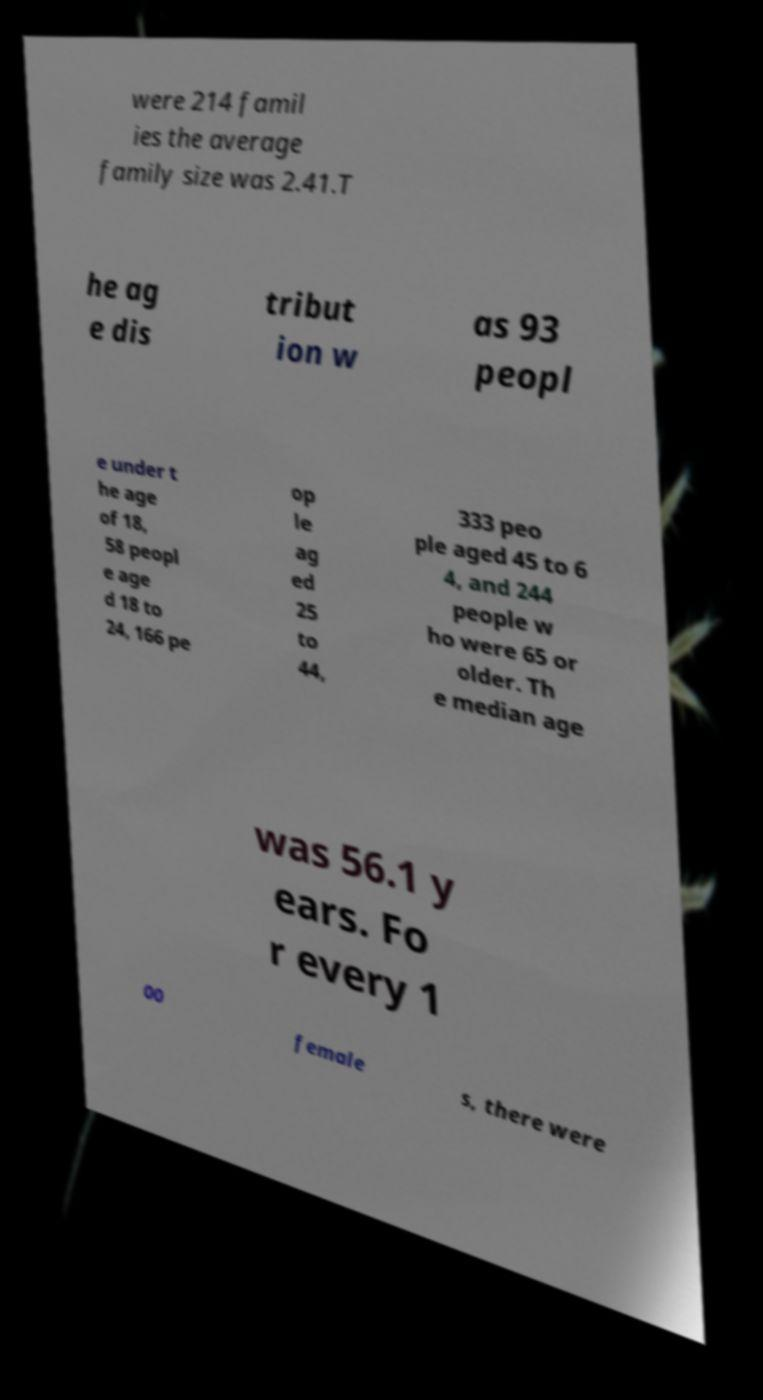I need the written content from this picture converted into text. Can you do that? were 214 famil ies the average family size was 2.41.T he ag e dis tribut ion w as 93 peopl e under t he age of 18, 58 peopl e age d 18 to 24, 166 pe op le ag ed 25 to 44, 333 peo ple aged 45 to 6 4, and 244 people w ho were 65 or older. Th e median age was 56.1 y ears. Fo r every 1 00 female s, there were 